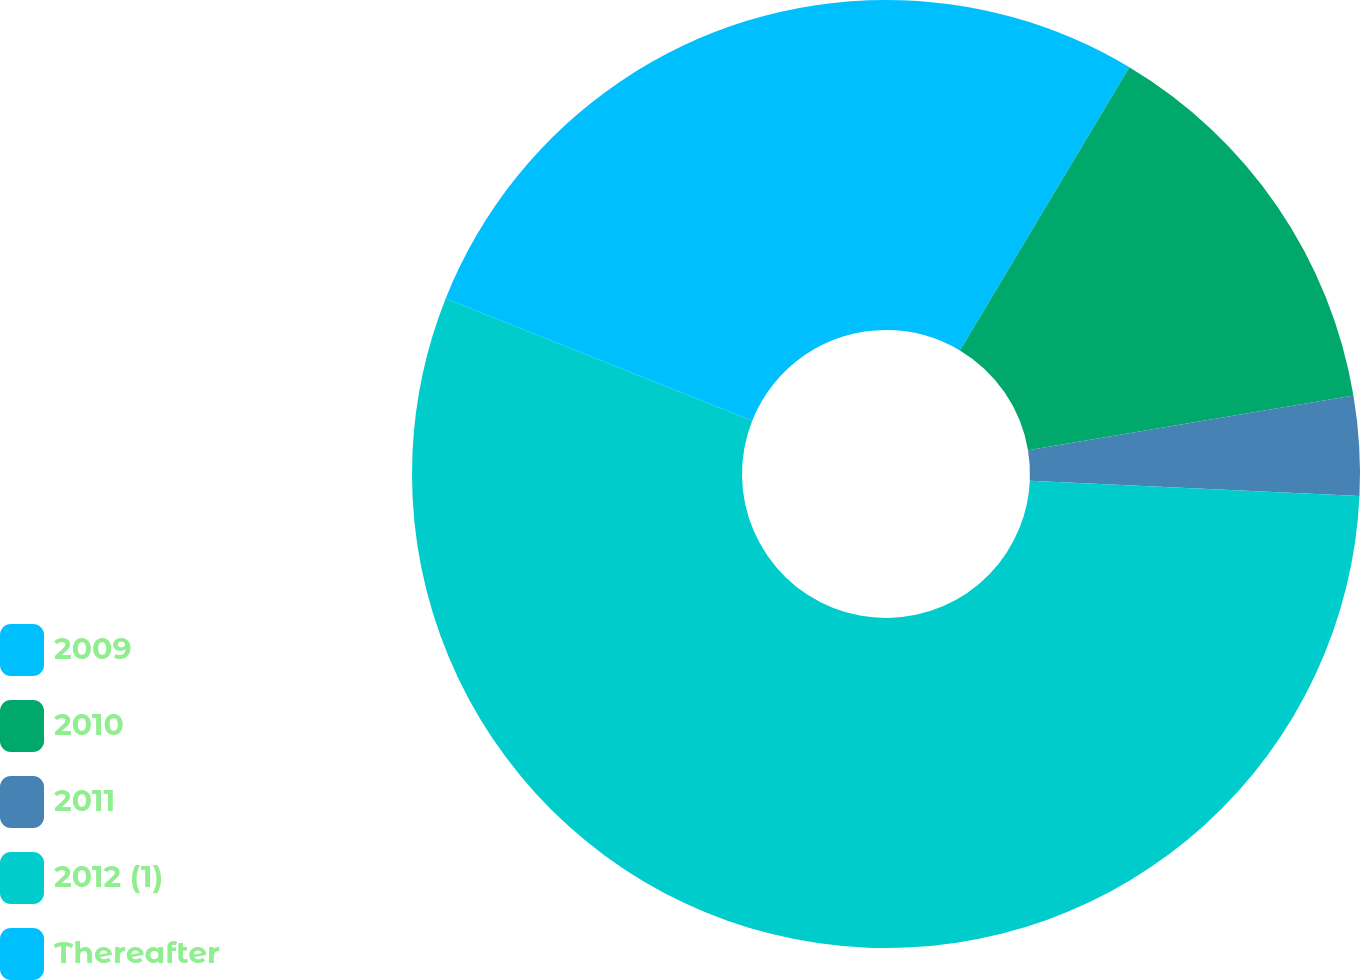Convert chart to OTSL. <chart><loc_0><loc_0><loc_500><loc_500><pie_chart><fcel>2009<fcel>2010<fcel>2011<fcel>2012 (1)<fcel>Thereafter<nl><fcel>8.58%<fcel>13.77%<fcel>3.39%<fcel>55.29%<fcel>18.96%<nl></chart> 